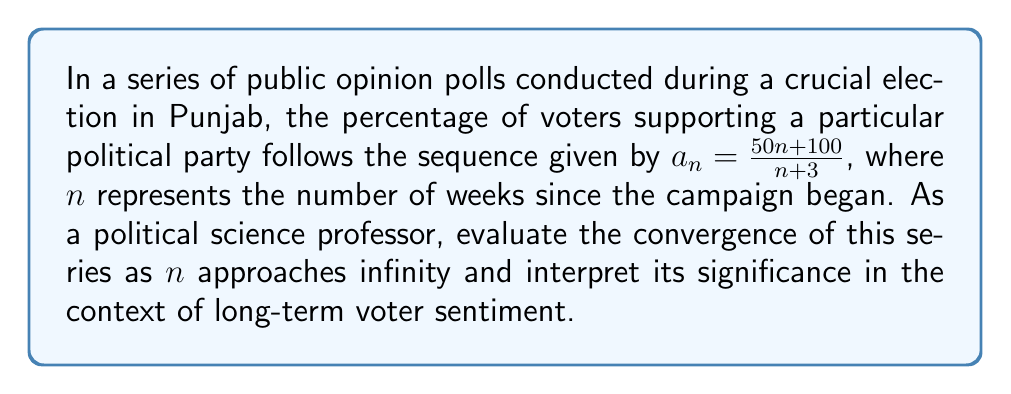Can you solve this math problem? To evaluate the convergence of this series, we'll follow these steps:

1) First, let's find the limit of the sequence as $n$ approaches infinity:

   $$\lim_{n \to \infty} a_n = \lim_{n \to \infty} \frac{50n+100}{n+3}$$

2) We can evaluate this limit by dividing both numerator and denominator by the highest power of $n$, which is $n^1$:

   $$\lim_{n \to \infty} \frac{50n+100}{n+3} = \lim_{n \to \infty} \frac{50 + \frac{100}{n}}{1 + \frac{3}{n}}$$

3) As $n$ approaches infinity, $\frac{100}{n}$ and $\frac{3}{n}$ approach 0:

   $$\lim_{n \to \infty} \frac{50 + \frac{100}{n}}{1 + \frac{3}{n}} = \frac{50 + 0}{1 + 0} = 50$$

4) Therefore, the sequence converges to 50.

5) In the context of voter sentiment, this means that as time progresses (as $n$ increases), the percentage of voters supporting the party approaches 50%.

6) The convergence of this series suggests that despite initial fluctuations, public opinion stabilizes around 50% support for the party in the long run.

7) As a political scientist, this could be interpreted as the party reaching a stable base of support, with half the electorate favoring them in the long term.
Answer: The series converges to 50%, indicating long-term stabilization of voter support at 50%. 